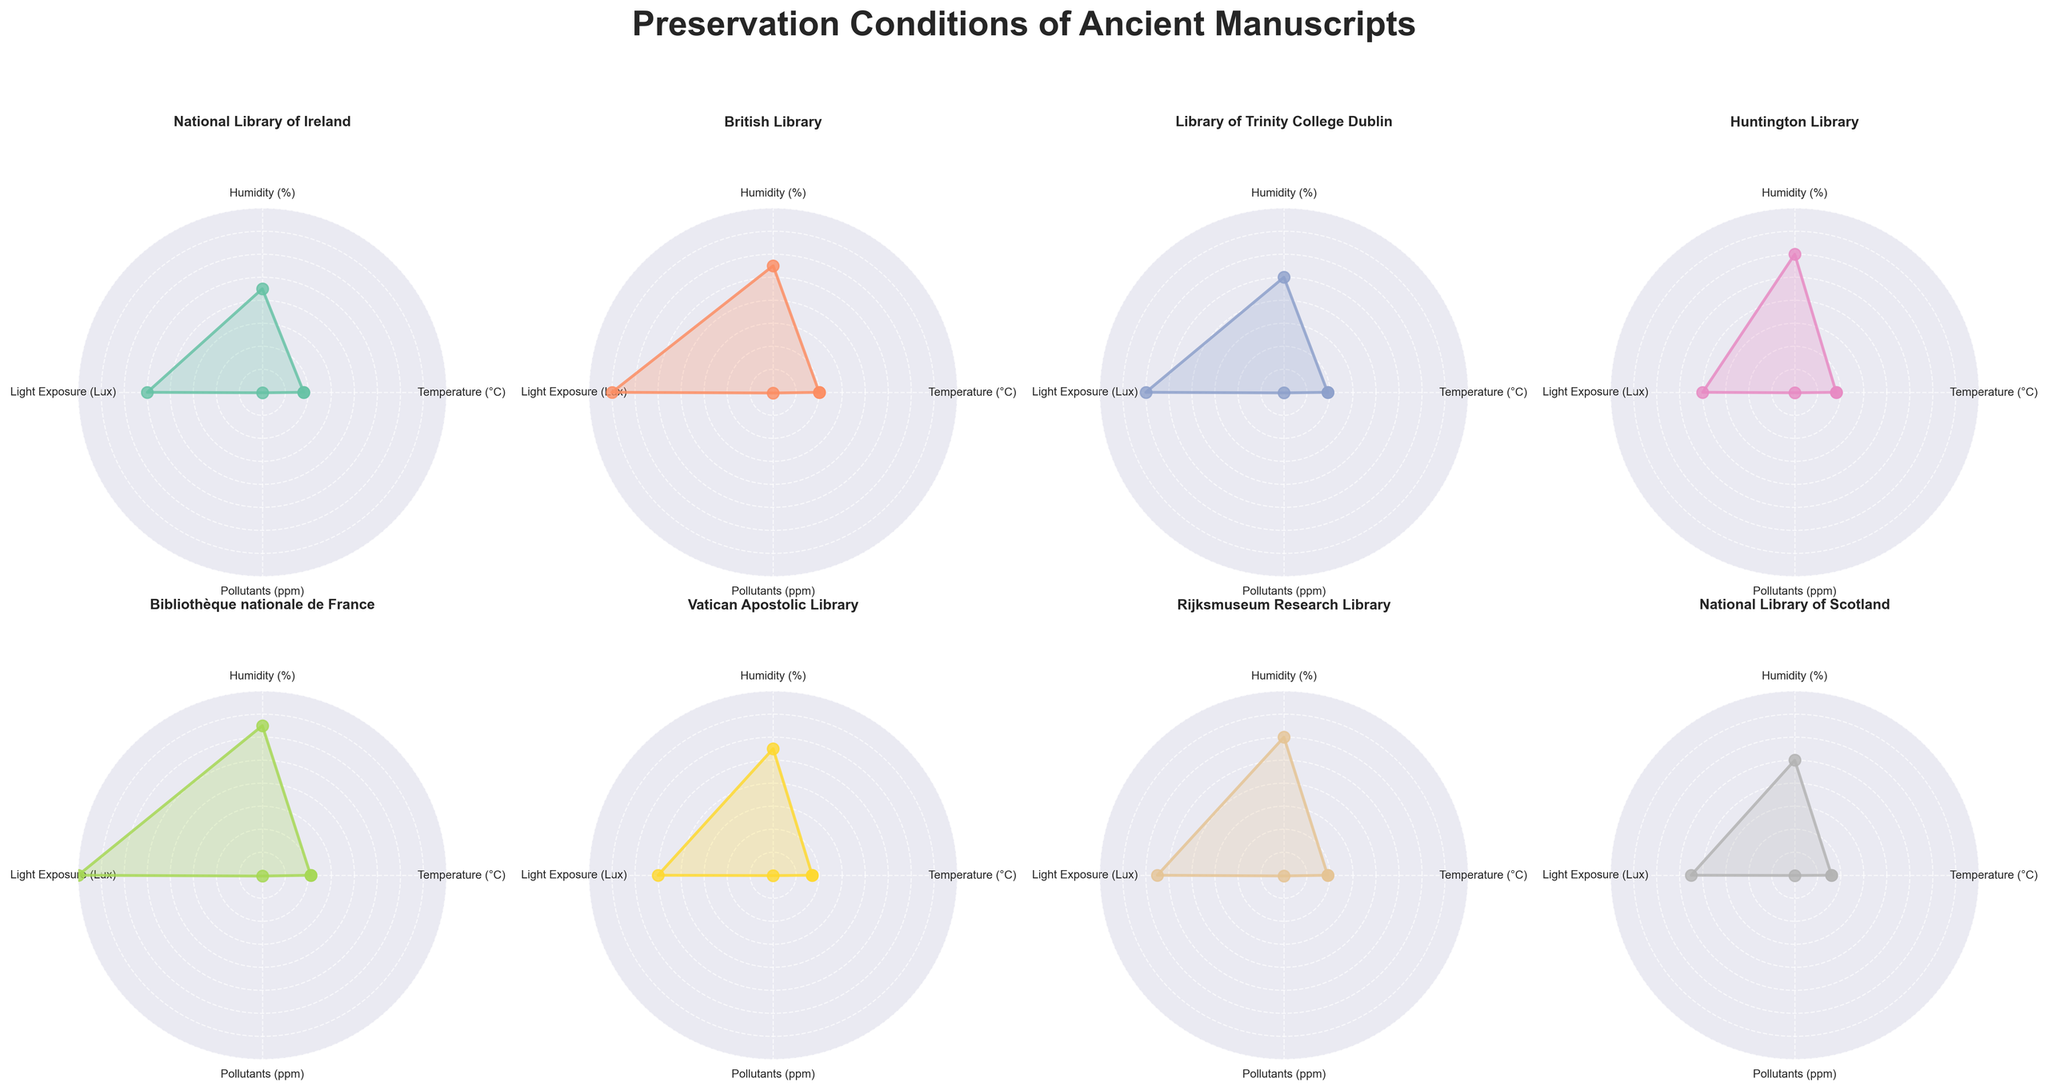What is the title of the figure? The title can be found at the top of the figure. It typically describes the main content or focus of the figure.
Answer: Preservation Conditions of Ancient Manuscripts Which library has the highest humidity? Look at the radar charts and identify the library whose "Humidity (%)" axis extends the furthest from the center.
Answer: Bibliothèque nationale de France What is the temperature range across all libraries? Identify the minimum and maximum values on the "Temperature (°C)" axis from all radar charts and calculate the range by subtracting the minimum from the maximum.
Answer: 16°C to 21°C How does the light exposure of the British Library compare to the Vatican Apostolic Library? Compare the lengths of the "Light Exposure (Lux)" axis in both the British Library and Vatican Apostolic Library radar charts. The British Library should have a longer axis.
Answer: The British Library has higher light exposure than the Vatican Apostolic Library Which library has the lowest pollutants level? Find the radar chart with the shortest "Pollutants (ppm)" axis. This would indicate the lowest pollutant levels.
Answer: National Library of Scotland What is the average humidity across all libraries? Sum the humidity values from all libraries and divide by the number of libraries. Calculation: (45+55+50+60+65+55+60+50)/8 = 55%
Answer: 55% Which has a greater light exposure: the National Library of Ireland or the Library of Trinity College Dublin? Compare the "Light Exposure (Lux)" axis in both radar charts.
Answer: Library of Trinity College Dublin Do any libraries have the same temperature and pollutant levels? Look for radar charts that have the same values on both "Temperature (°C)" and "Pollutants (ppm)" axes.
Answer: No What is the difference in temperature between the Huntington Library and the Rijksmuseum Research Library? Subtract the temperature value of the Huntington Library from that of the Rijksmuseum Research Library. Calculation: 19°C - 18°C = 1°C
Answer: 1°C What is the average pollutants level among libraries with humidity above 60%? First, find libraries with humidity above 60%: Huntington Library (60%), Bibliothèque nationale de France (65%), and Rijksmuseum Research Library (60%). Average pollutants: (0.2+0.35+0.3)/3 = 0.2833 ppm
Answer: 0.2833 ppm 